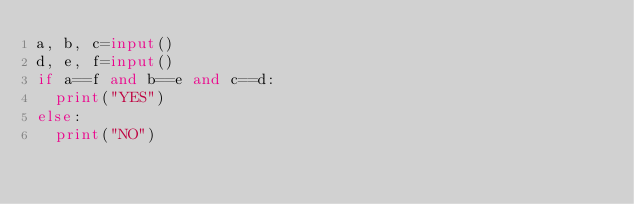<code> <loc_0><loc_0><loc_500><loc_500><_Python_>a, b, c=input()
d, e, f=input()
if a==f and b==e and c==d:
  print("YES")
else:
  print("NO")</code> 